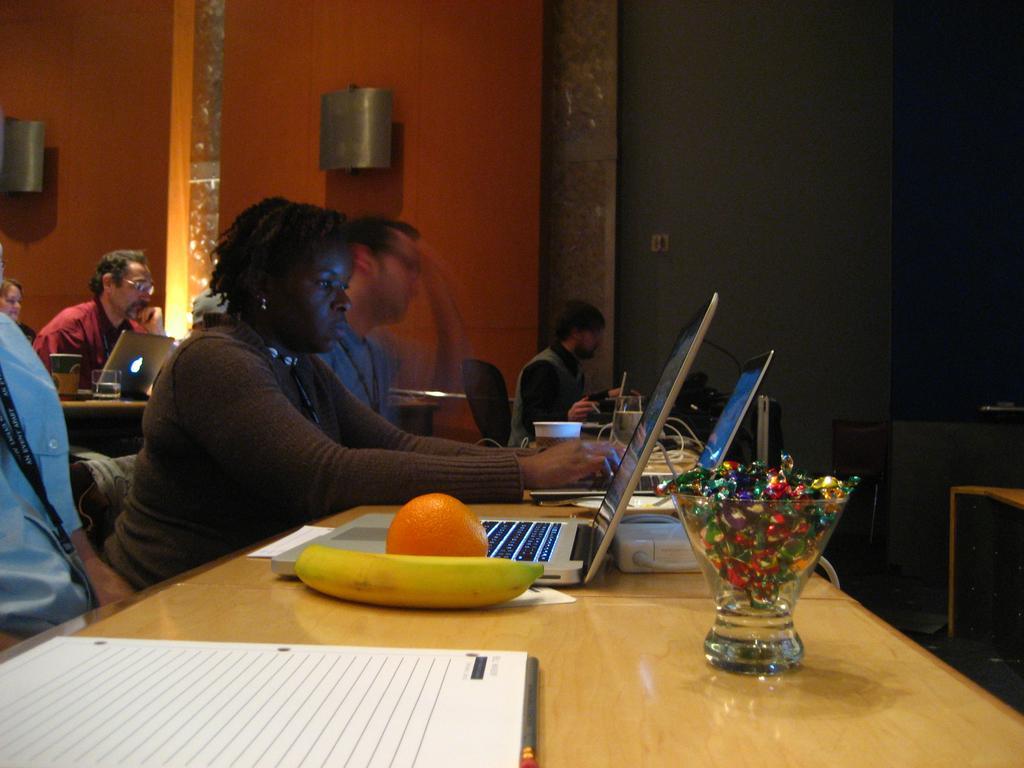How would you summarize this image in a sentence or two? In the image we can see there are people who are sitting on chair and on table there are laptop and fruits. 